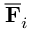<formula> <loc_0><loc_0><loc_500><loc_500>\overline { F } _ { i }</formula> 